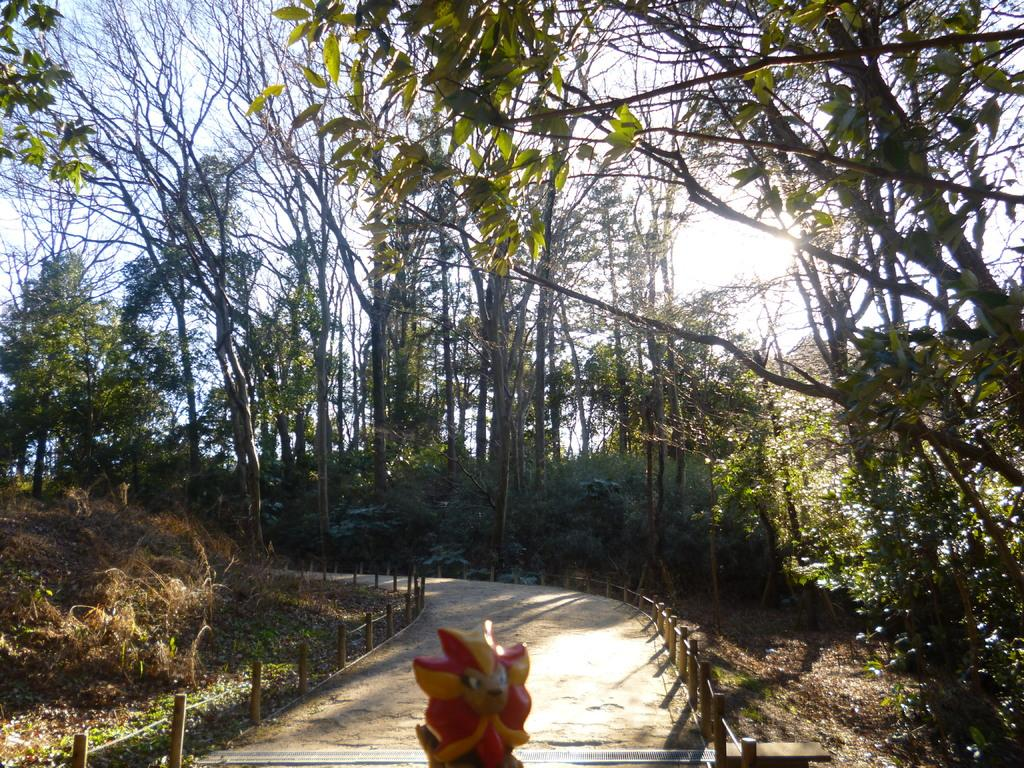What type of natural elements can be seen in the image? There are trees and plants in the image. What man-made object is present in the image? There is a toy in the image. Is there any indication of a path or walkway in the image? Yes, there is a path in the image. How would you describe the weather based on the image? The sky is cloudy in the image, suggesting a potentially overcast or cloudy day. What level of difficulty is the beginner's crib in the image? There is no crib present in the image, and therefore no difficulty level can be determined. What type of fiction is depicted in the image? The image does not depict any fiction; it features trees, plants, a toy, a path, and a cloudy sky. 